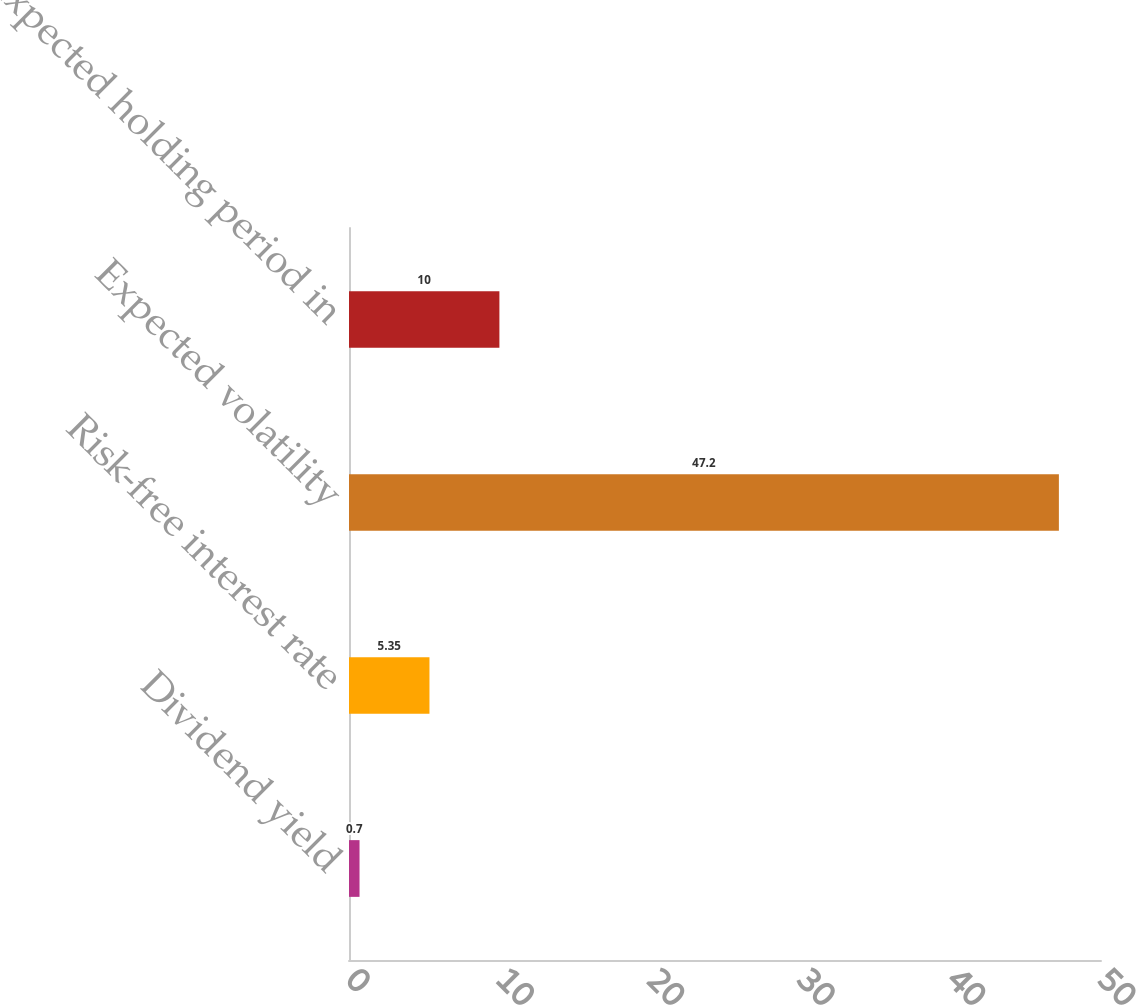<chart> <loc_0><loc_0><loc_500><loc_500><bar_chart><fcel>Dividend yield<fcel>Risk-free interest rate<fcel>Expected volatility<fcel>Expected holding period in<nl><fcel>0.7<fcel>5.35<fcel>47.2<fcel>10<nl></chart> 